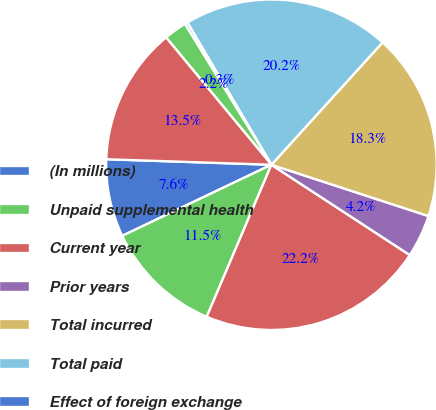Convert chart. <chart><loc_0><loc_0><loc_500><loc_500><pie_chart><fcel>(In millions)<fcel>Unpaid supplemental health<fcel>Current year<fcel>Prior years<fcel>Total incurred<fcel>Total paid<fcel>Effect of foreign exchange<fcel>Unpaid life claims end of year<fcel>Total liability for unpaid<nl><fcel>7.61%<fcel>11.52%<fcel>22.2%<fcel>4.18%<fcel>18.29%<fcel>20.24%<fcel>0.27%<fcel>2.23%<fcel>13.47%<nl></chart> 